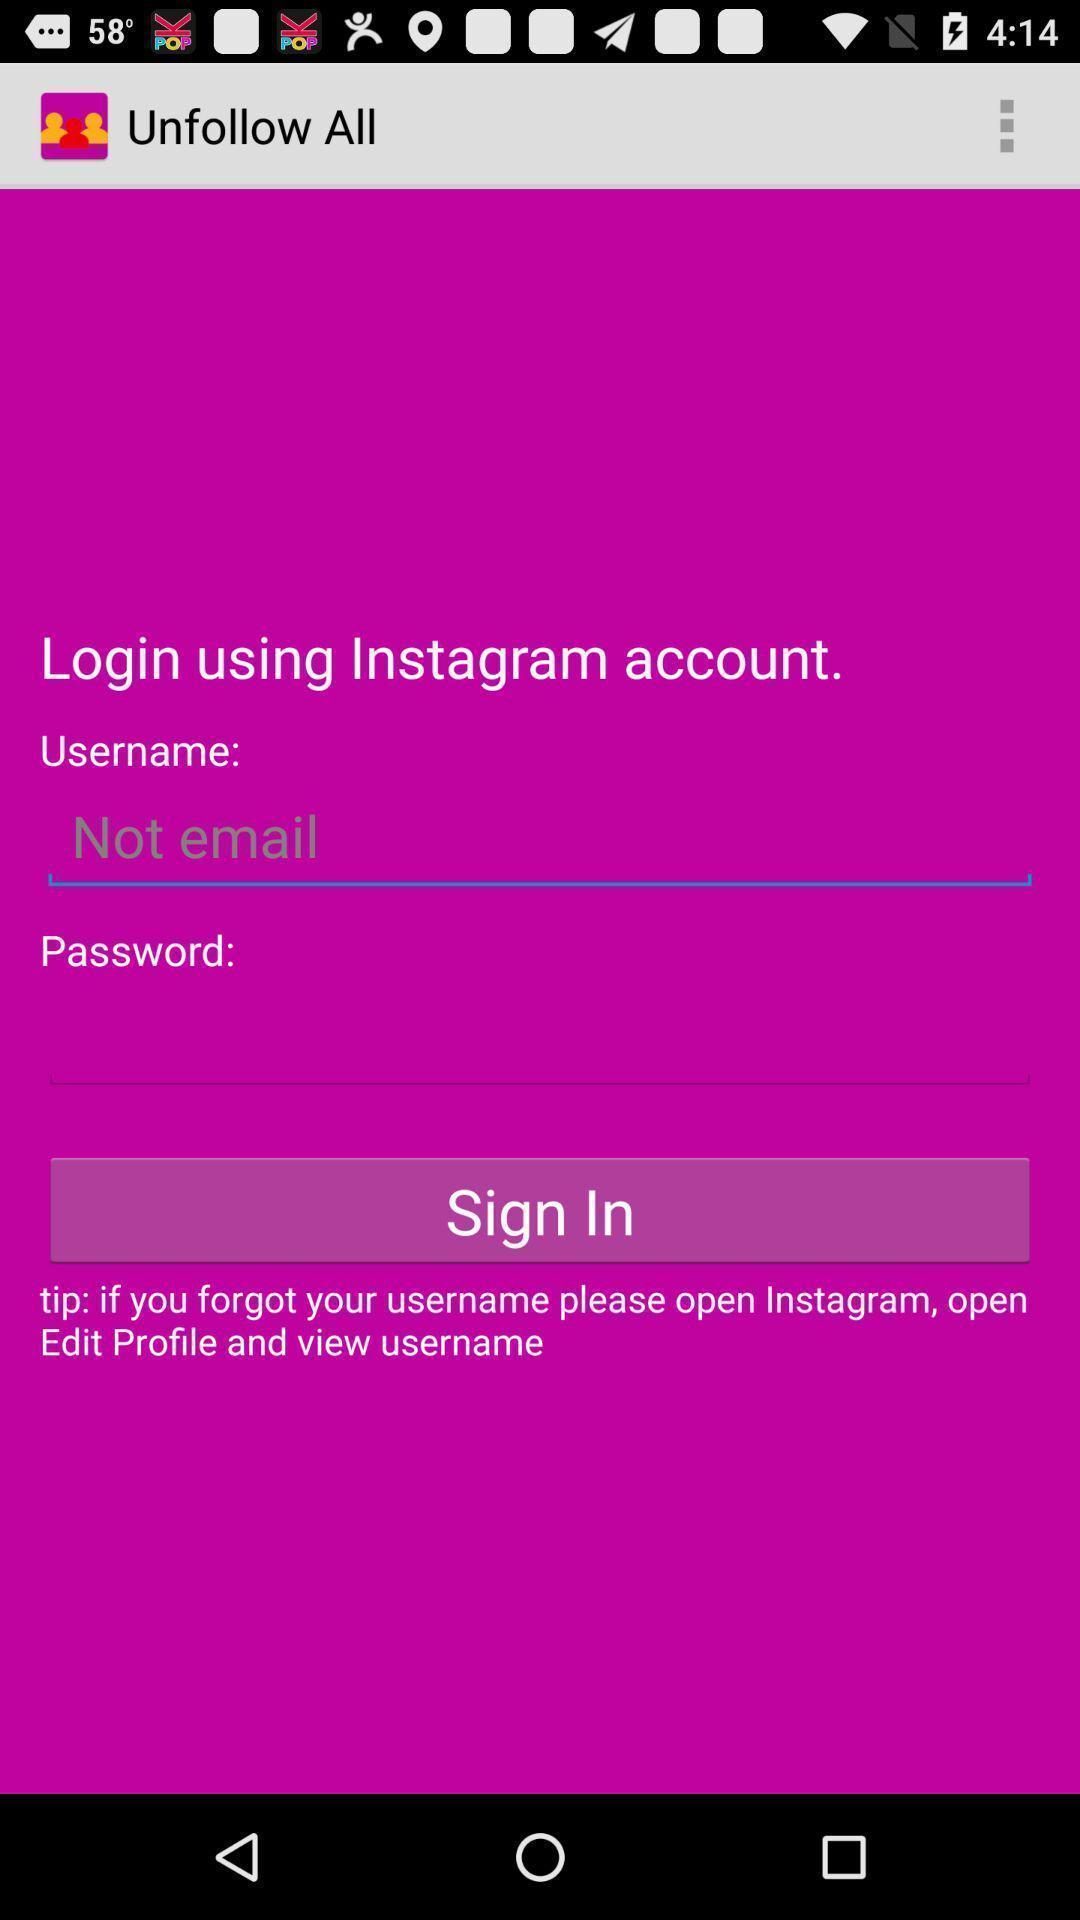What details can you identify in this image? Sign in page of the app. 